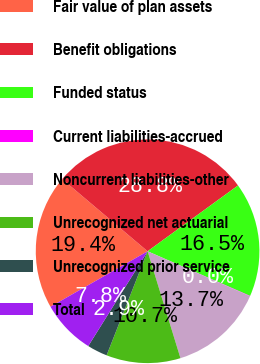Convert chart to OTSL. <chart><loc_0><loc_0><loc_500><loc_500><pie_chart><fcel>Fair value of plan assets<fcel>Benefit obligations<fcel>Funded status<fcel>Current liabilities-accrued<fcel>Noncurrent liabilities-other<fcel>Unrecognized net actuarial<fcel>Unrecognized prior service<fcel>Total<nl><fcel>19.43%<fcel>28.82%<fcel>16.55%<fcel>0.05%<fcel>13.67%<fcel>10.72%<fcel>2.93%<fcel>7.84%<nl></chart> 